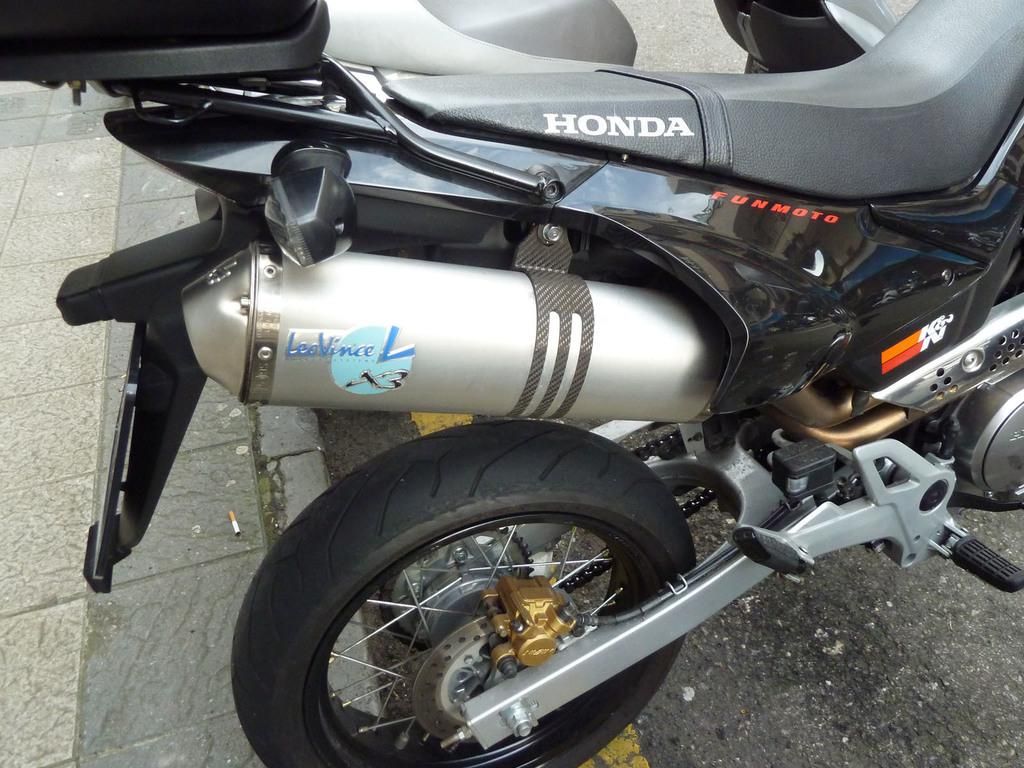What is the main subject of the image? The main subject of the image is a motorcycle. Where is the motorcycle located? The motorcycle is on the road. What is the small object visible on the road? There is a cigarette bud on the road. What type of path is visible in the image? There is a footpath in the image. What type of circle is visible on the motorcycle in the image? There is no circle visible on the motorcycle in the image. What type of rod can be seen attached to the motorcycle in the image? There is no rod visible attached to the motorcycle in the image. 